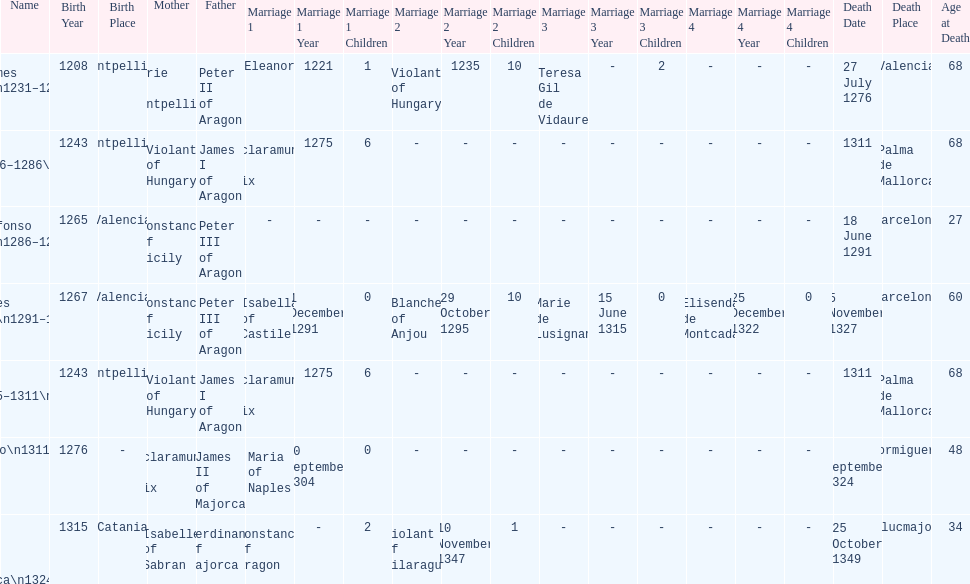James i and james ii both died at what age? 68. Could you parse the entire table as a dict? {'header': ['Name', 'Birth Year', 'Birth Place', 'Mother', 'Father', 'Marriage 1', 'Marriage 1 Year', 'Marriage 1 Children', 'Marriage 2', 'Marriage 2 Year', 'Marriage 2 Children', 'Marriage 3', 'Marriage 3 Year', 'Marriage 3 Children', 'Marriage 4', 'Marriage 4 Year', 'Marriage 4 Children', 'Death Date', 'Death Place', 'Age at Death'], 'rows': [['James I\\n1231–1276', '1208', 'Montpellier', 'Marie of Montpellier', 'Peter II of Aragon', 'Eleanor', '1221', '1', 'Violant of Hungary', '1235', '10', 'Teresa Gil de Vidaure', '-', '2', '-', '-', '-', '27 July 1276', 'Valencia', '68'], ['James II\\n1276–1286\\n(first rule)', '1243', 'Montpellier', 'Violant of Hungary', 'James I of Aragon', 'Esclaramunda of Foix', '1275', '6', '-', '-', '-', '-', '-', '-', '-', '-', '-', '1311', 'Palma de Mallorca', '68'], ['Alfonso I\\n1286–1291', '1265', 'Valencia', 'Constance of Sicily', 'Peter III of Aragon', '-', '-', '-', '-', '-', '-', '-', '-', '-', '-', '-', '-', '18 June 1291', 'Barcelona', '27'], ['James III\\n1291–1295', '1267', 'Valencia', 'Constance of Sicily', 'Peter III of Aragon', 'Isabella of Castile', '1 December 1291', '0', 'Blanche of Anjou', '29 October 1295', '10', 'Marie de Lusignan', '15 June 1315', '0', 'Elisenda de Montcada', '25 December 1322', '0', '5 November 1327', 'Barcelona', '60'], ['James II\\n1295–1311\\n(second rule)', '1243', 'Montpellier', 'Violant of Hungary', 'James I of Aragon', 'Esclaramunda of Foix', '1275', '6', '-', '-', '-', '-', '-', '-', '-', '-', '-', '1311', 'Palma de Mallorca', '68'], ['Sancho\\n1311–1324', '1276', '-', 'Esclaramunda of Foix', 'James II of Majorca', 'Maria of Naples', '20 September 1304', '0', '-', '-', '-', '-', '-', '-', '-', '-', '-', '4 September 1324', 'Formiguera', '48'], ['James III of Majorca\\n1324–1344', '1315', 'Catania', 'Isabelle of Sabran', 'Ferdinand of Majorca', 'Constance of Aragon', '-', '2', 'Violant of Vilaragut', '10 November 1347', '1', '-', '-', '-', '-', '-', '-', '25 October 1349', 'Llucmajor', '34']]} 